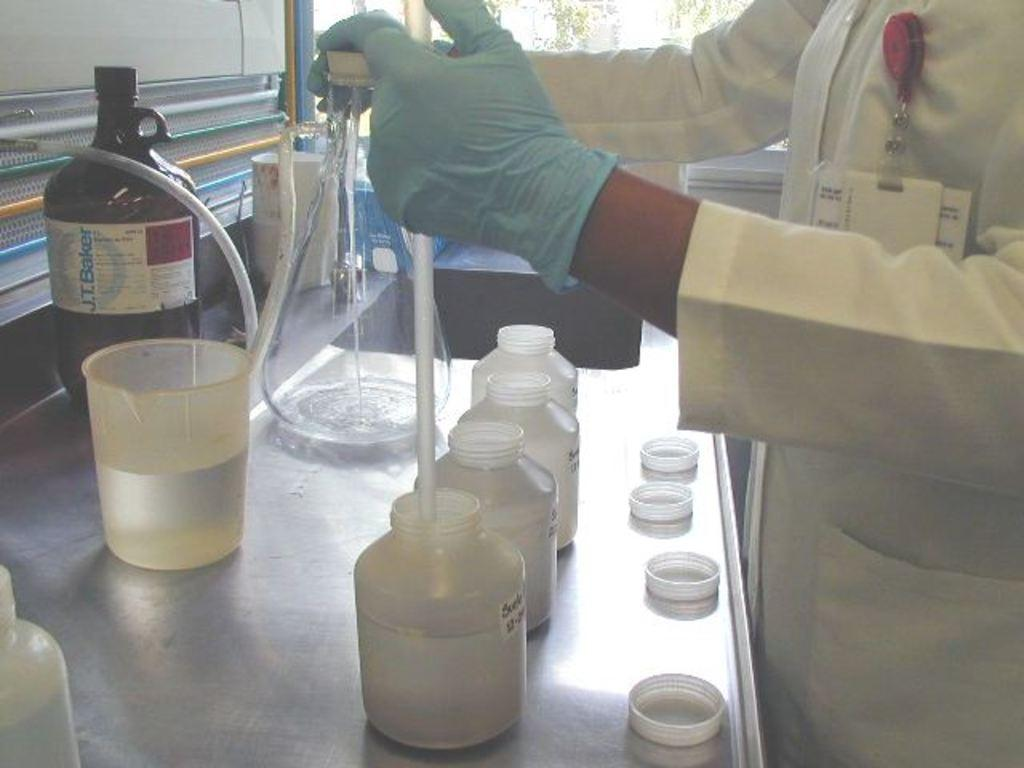<image>
Write a terse but informative summary of the picture. a scientist in a lab in front of jars and a bottle of J.T. Baker 